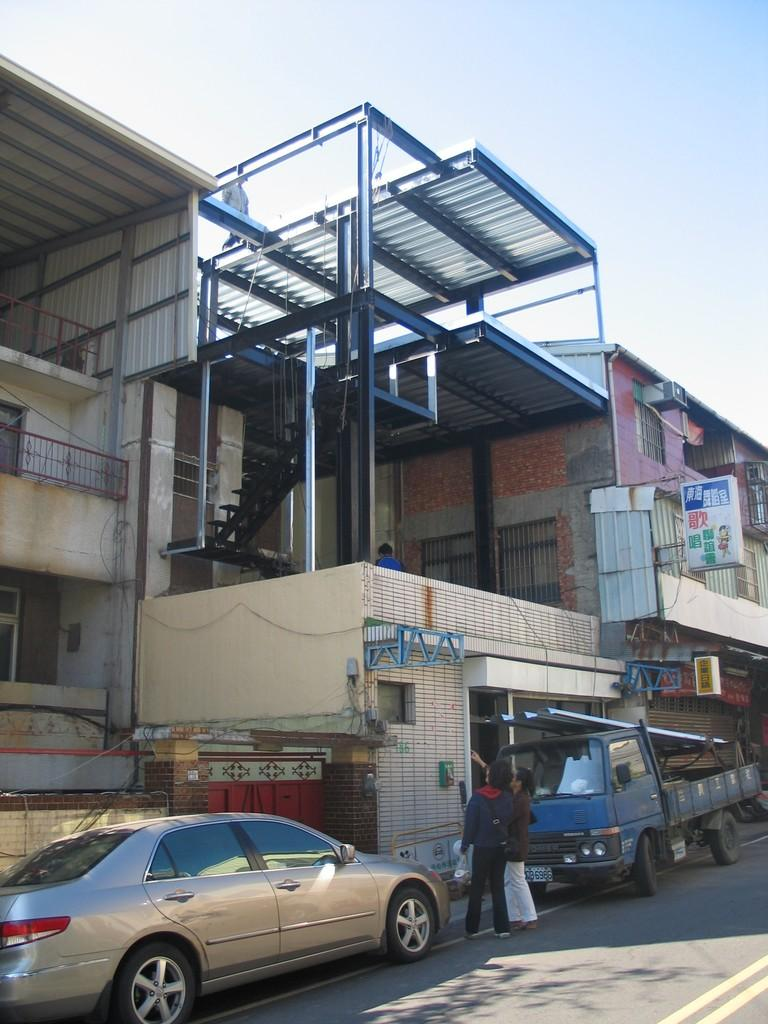What type of structures can be seen in the image? There are buildings in the image. What architectural feature is present in the image? There are stairs, boards, and railings in the image. What is happening on the road in the image? There are vehicles and people on the road in the image. What is visible at the top of the image? The sky is visible at the top of the image. What month is it in the image? The month cannot be determined from the image, as it does not contain any information about the time of year. How many girls are present in the image? There are no girls present in the image. What sound can be heard coming from the bell in the image? There is no bell present in the image. 